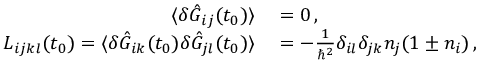<formula> <loc_0><loc_0><loc_500><loc_500>\begin{array} { r l } { \langle \delta \hat { G } _ { i j } ( t _ { 0 } ) \rangle } & = 0 \, , } \\ { L _ { i j k l } ( t _ { 0 } ) = \langle \delta \hat { G } _ { i k } ( t _ { 0 } ) \delta \hat { G } _ { j l } ( t _ { 0 } ) \rangle } & = - \frac { 1 } { \hbar { ^ } { 2 } } \delta _ { i l } \delta _ { j k } n _ { j } ( 1 \pm n _ { i } ) \, , \quad } \end{array}</formula> 